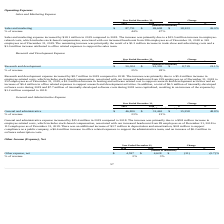According to Everbridge's financial document, What was the increase in the Sales and marketing expense in 2019? According to the financial document, $18.1 million. The relevant text states: "Sales and marketing expense increased by $18.1 million in 2019 compared to 2018. The increase was primarily due to a $15.5 million increase in employee- re..." Also, What was increase in the trade show and advertising cost in 2019? According to the financial document, $1.2 million. The relevant text states: "remaining increase was principally the result of a $1.2 million increase in trade show and advertising costs and a $1.0 million increase attributed to office relate..." Also, What was the % of revenue in 2019 and 2018? The document shows two values: 44 and 47 (percentage). From the document: "% of revenue 44% 47% % of revenue 44% 47%..." Also, can you calculate: What was the average Sales and marketing expenses for 2018 and 2019? To answer this question, I need to perform calculations using the financial data. The calculation is: (87,731 + 69,608) / 2, which equals 78669.5 (in thousands). This is based on the information: "Sales and marketing $ 87,731 $ 69,608 $ 18,123 26.0% Sales and marketing $ 87,731 $ 69,608 $ 18,123 26.0%..." The key data points involved are: 69,608, 87,731. Additionally, In which year was Sales and marketing expenses less than 90,000 thousands? The document shows two values: 2019 and 2018. Locate and analyze sales and marketing in row 4. From the document: "2019 2018 $ % 2019 2018 $ %..." Also, can you calculate: What is the change in the % of revenue from 2018 to 2019? Based on the calculation: 44 - 47, the result is -3 (percentage). This is based on the information: "% of revenue 44% 47% % of revenue 44% 47%..." The key data points involved are: 44, 47. 